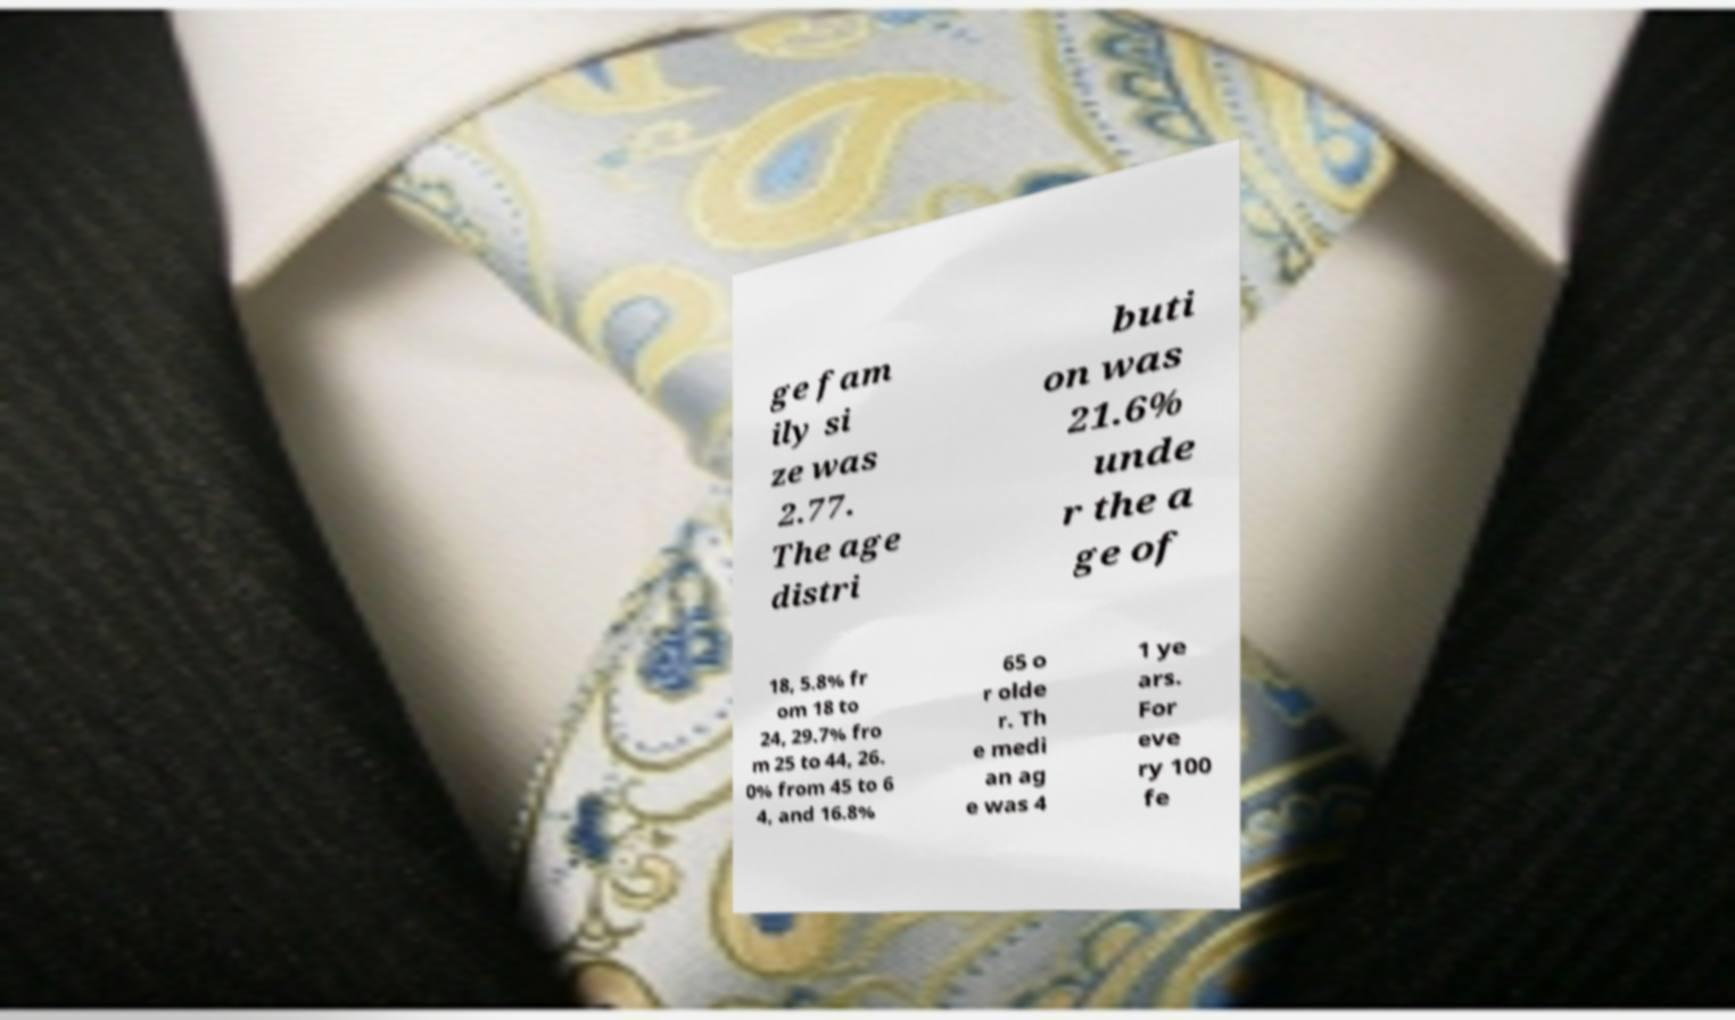Please read and relay the text visible in this image. What does it say? ge fam ily si ze was 2.77. The age distri buti on was 21.6% unde r the a ge of 18, 5.8% fr om 18 to 24, 29.7% fro m 25 to 44, 26. 0% from 45 to 6 4, and 16.8% 65 o r olde r. Th e medi an ag e was 4 1 ye ars. For eve ry 100 fe 